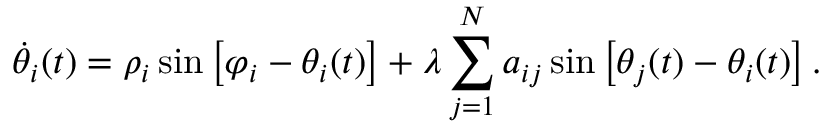Convert formula to latex. <formula><loc_0><loc_0><loc_500><loc_500>\dot { \theta } _ { i } ( t ) = \rho _ { i } \sin \left [ \varphi _ { i } - \theta _ { i } ( t ) \right ] + \lambda \sum _ { j = 1 } ^ { N } a _ { i j } \sin \left [ \theta _ { j } ( t ) - \theta _ { i } ( t ) \right ] .</formula> 